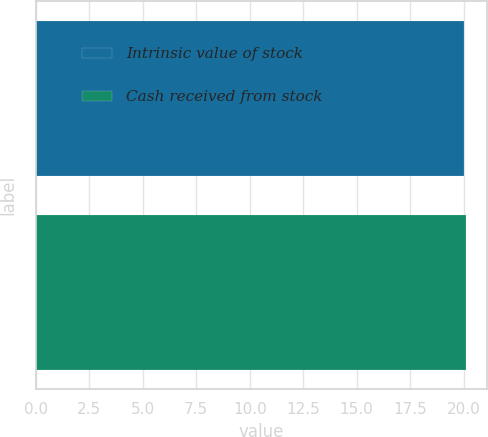Convert chart to OTSL. <chart><loc_0><loc_0><loc_500><loc_500><bar_chart><fcel>Intrinsic value of stock<fcel>Cash received from stock<nl><fcel>20<fcel>20.1<nl></chart> 